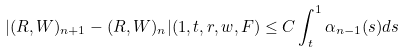Convert formula to latex. <formula><loc_0><loc_0><loc_500><loc_500>| ( R , W ) _ { n + 1 } - ( R , W ) _ { n } | ( 1 , t , r , w , F ) \leq C \int _ { t } ^ { 1 } \alpha _ { n - 1 } ( s ) d s</formula> 